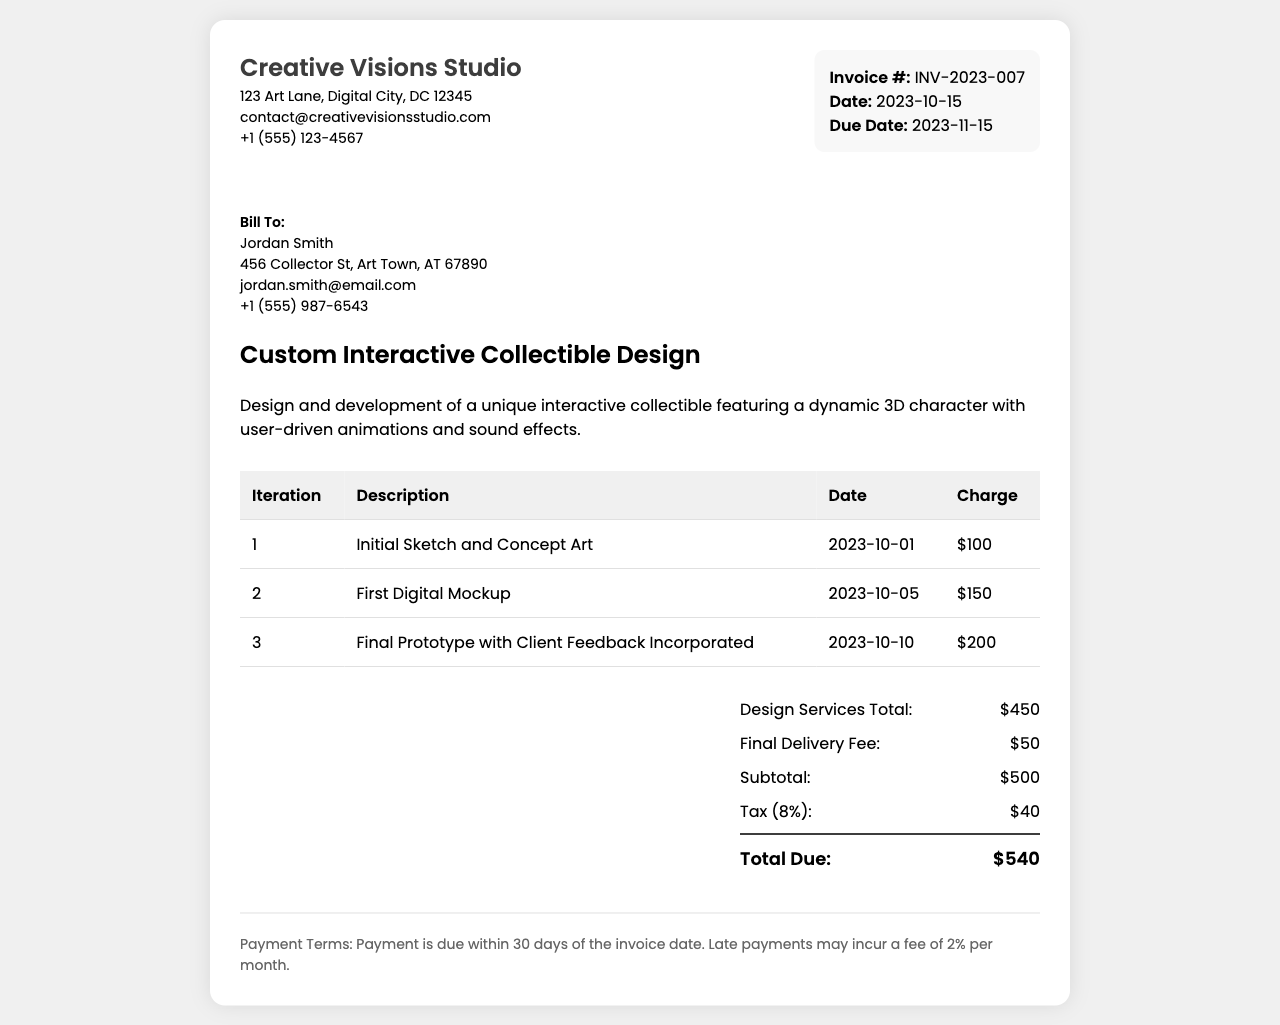What is the invoice number? The invoice number is found in the invoice details section, which reads "Invoice #: INV-2023-007".
Answer: INV-2023-007 Who is the client? The client information is listed under "Bill To:", and the name is shown as Jordan Smith.
Answer: Jordan Smith What is the total due amount? The total due amount is summarized at the bottom of the charges section, which is "$540".
Answer: $540 What date is the invoice issued? The invoice date is indicated in the invoice details section, stating "Date: 2023-10-15".
Answer: 2023-10-15 How many design iterations were charged? The number of iterations can be counted from the table, which lists three iterations.
Answer: 3 What is the subtotal amount? The subtotal amount is listed in the charges section and is "Subtotal: $500".
Answer: $500 When is the payment due? The payment terms state that payment is due within 30 days of the invoice date, giving a due date of 2023-11-15.
Answer: 2023-11-15 What is the tax rate applied? The tax is calculated as 8%, as indicated in the charges section mentioning "Tax (8%): $40".
Answer: 8% What service is being invoiced? The project description specifies "Custom Interactive Collectible Design".
Answer: Custom Interactive Collectible Design 